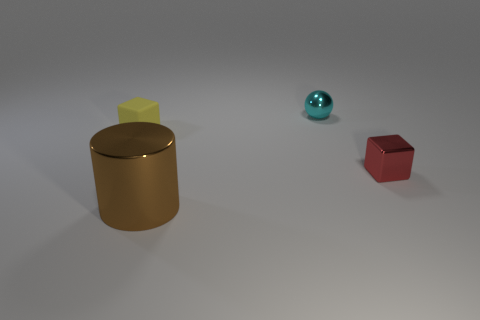Is there anything else that has the same shape as the red object?
Your answer should be very brief. Yes. Are there the same number of shiny balls in front of the big cylinder and large red matte cylinders?
Provide a succinct answer. Yes. How many tiny objects are both to the right of the yellow matte object and in front of the cyan object?
Provide a short and direct response. 1. What is the size of the metallic thing that is the same shape as the rubber object?
Offer a very short reply. Small. What number of small balls are made of the same material as the red cube?
Provide a succinct answer. 1. Is the number of cyan spheres in front of the small matte object less than the number of big brown shiny things?
Your response must be concise. Yes. How many cyan shiny blocks are there?
Make the answer very short. 0. Is the tiny rubber thing the same shape as the large object?
Make the answer very short. No. There is a block that is on the left side of the tiny metal object in front of the tiny yellow rubber object; how big is it?
Ensure brevity in your answer.  Small. Are there any purple rubber cylinders that have the same size as the red metal thing?
Your response must be concise. No. 